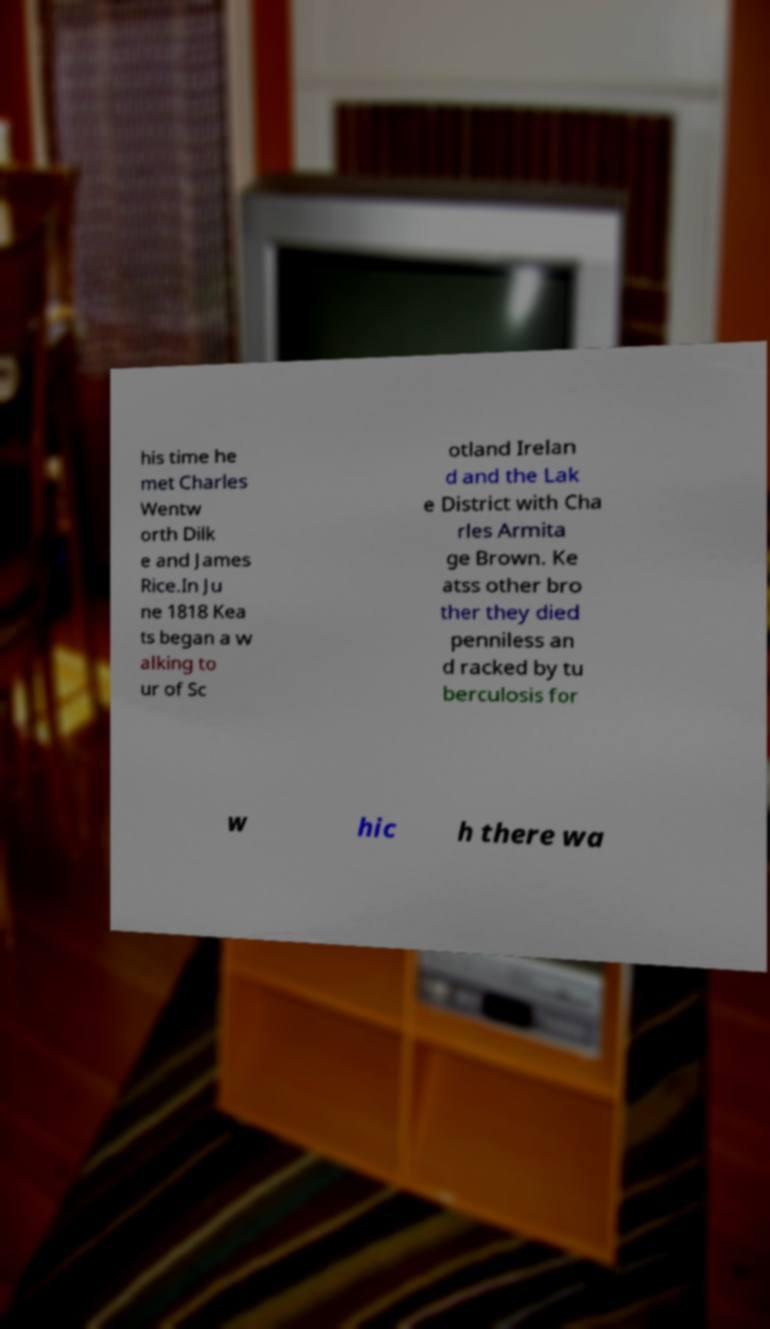There's text embedded in this image that I need extracted. Can you transcribe it verbatim? his time he met Charles Wentw orth Dilk e and James Rice.In Ju ne 1818 Kea ts began a w alking to ur of Sc otland Irelan d and the Lak e District with Cha rles Armita ge Brown. Ke atss other bro ther they died penniless an d racked by tu berculosis for w hic h there wa 